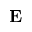Convert formula to latex. <formula><loc_0><loc_0><loc_500><loc_500>{ E }</formula> 